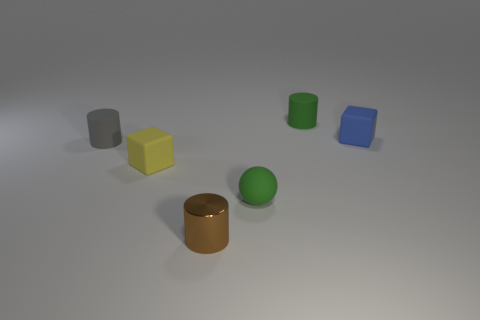Subtract all small rubber cylinders. How many cylinders are left? 1 Subtract 1 cylinders. How many cylinders are left? 2 Add 2 big gray matte balls. How many objects exist? 8 Subtract all yellow cylinders. Subtract all blue balls. How many cylinders are left? 3 Subtract all spheres. How many objects are left? 5 Add 3 green cylinders. How many green cylinders are left? 4 Add 5 yellow rubber things. How many yellow rubber things exist? 6 Subtract 0 blue balls. How many objects are left? 6 Subtract all small cyan objects. Subtract all matte cylinders. How many objects are left? 4 